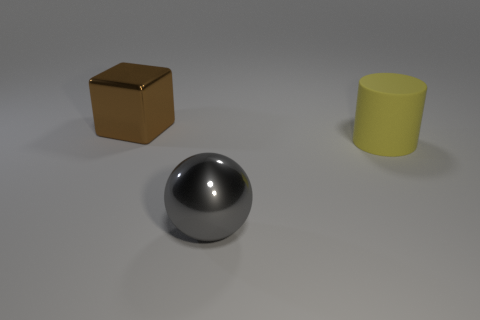Add 3 big yellow matte cylinders. How many objects exist? 6 Subtract all blocks. How many objects are left? 2 Add 3 small gray cylinders. How many small gray cylinders exist? 3 Subtract 0 gray cylinders. How many objects are left? 3 Subtract all big yellow things. Subtract all large matte cylinders. How many objects are left? 1 Add 2 big yellow cylinders. How many big yellow cylinders are left? 3 